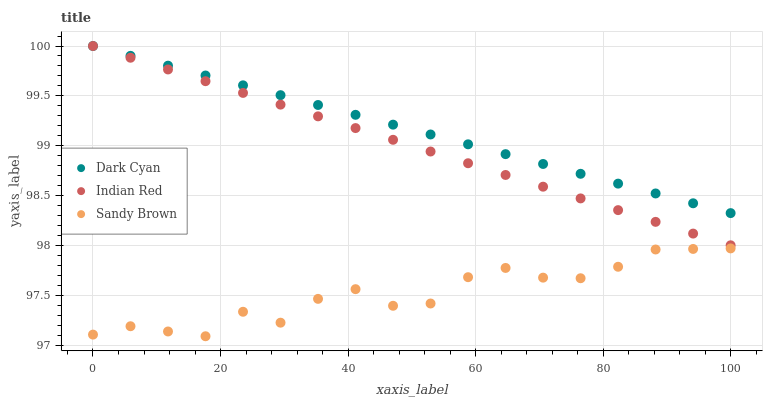Does Sandy Brown have the minimum area under the curve?
Answer yes or no. Yes. Does Dark Cyan have the maximum area under the curve?
Answer yes or no. Yes. Does Indian Red have the minimum area under the curve?
Answer yes or no. No. Does Indian Red have the maximum area under the curve?
Answer yes or no. No. Is Dark Cyan the smoothest?
Answer yes or no. Yes. Is Sandy Brown the roughest?
Answer yes or no. Yes. Is Indian Red the smoothest?
Answer yes or no. No. Is Indian Red the roughest?
Answer yes or no. No. Does Sandy Brown have the lowest value?
Answer yes or no. Yes. Does Indian Red have the lowest value?
Answer yes or no. No. Does Indian Red have the highest value?
Answer yes or no. Yes. Does Sandy Brown have the highest value?
Answer yes or no. No. Is Sandy Brown less than Indian Red?
Answer yes or no. Yes. Is Dark Cyan greater than Sandy Brown?
Answer yes or no. Yes. Does Indian Red intersect Dark Cyan?
Answer yes or no. Yes. Is Indian Red less than Dark Cyan?
Answer yes or no. No. Is Indian Red greater than Dark Cyan?
Answer yes or no. No. Does Sandy Brown intersect Indian Red?
Answer yes or no. No. 